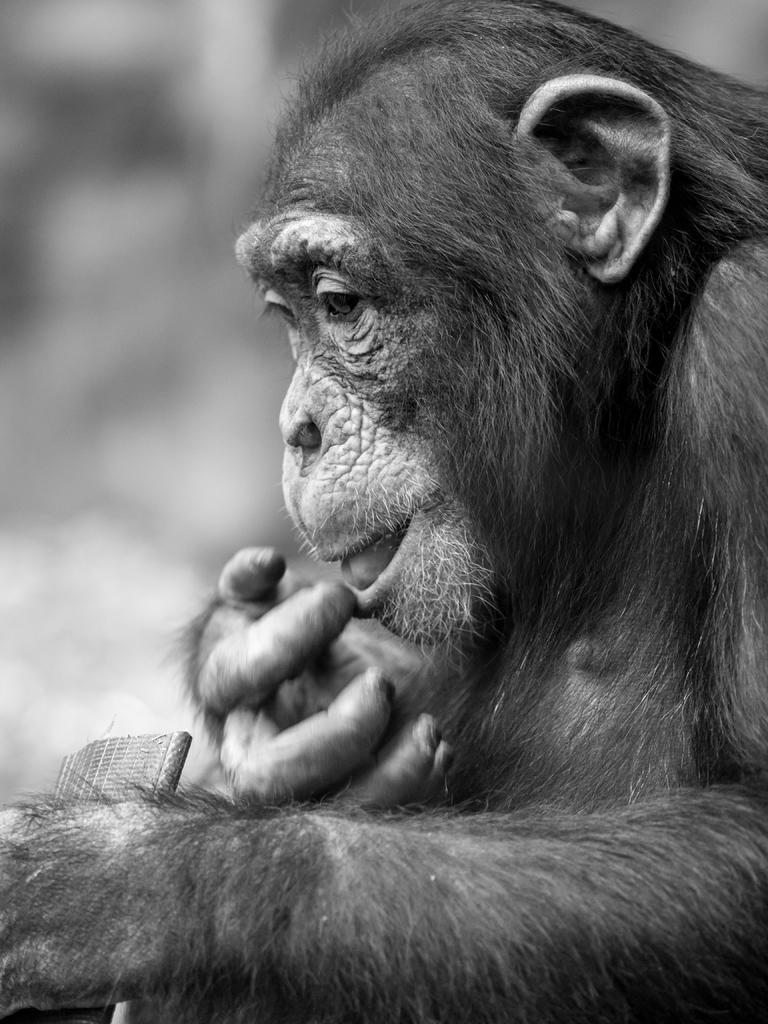What type of animal is in the image? There is a chimpanzee in the image. What type of insect is present in the image? There is no insect present in the image; it features a chimpanzee. What type of army is depicted in the image? There is no army present in the image; it features a chimpanzee. 